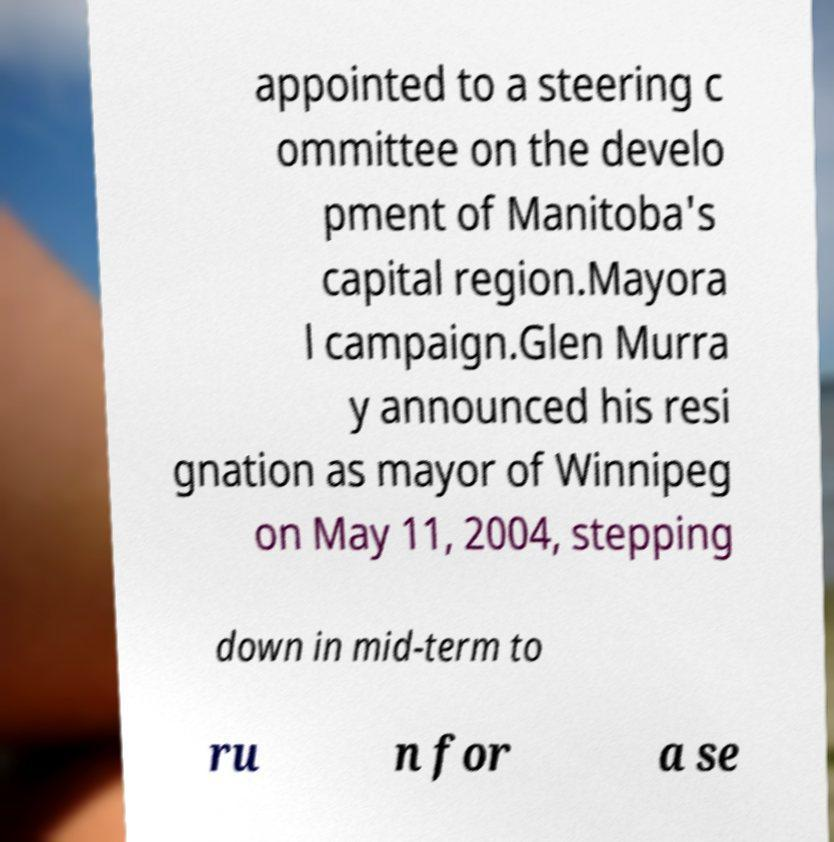I need the written content from this picture converted into text. Can you do that? appointed to a steering c ommittee on the develo pment of Manitoba's capital region.Mayora l campaign.Glen Murra y announced his resi gnation as mayor of Winnipeg on May 11, 2004, stepping down in mid-term to ru n for a se 